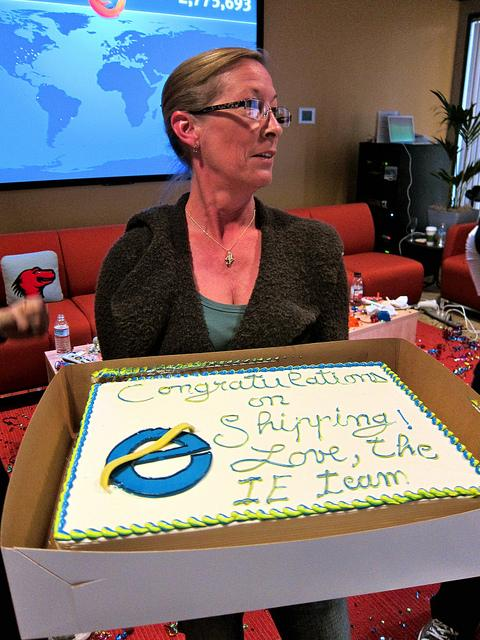Where is this cake and woman located? office 